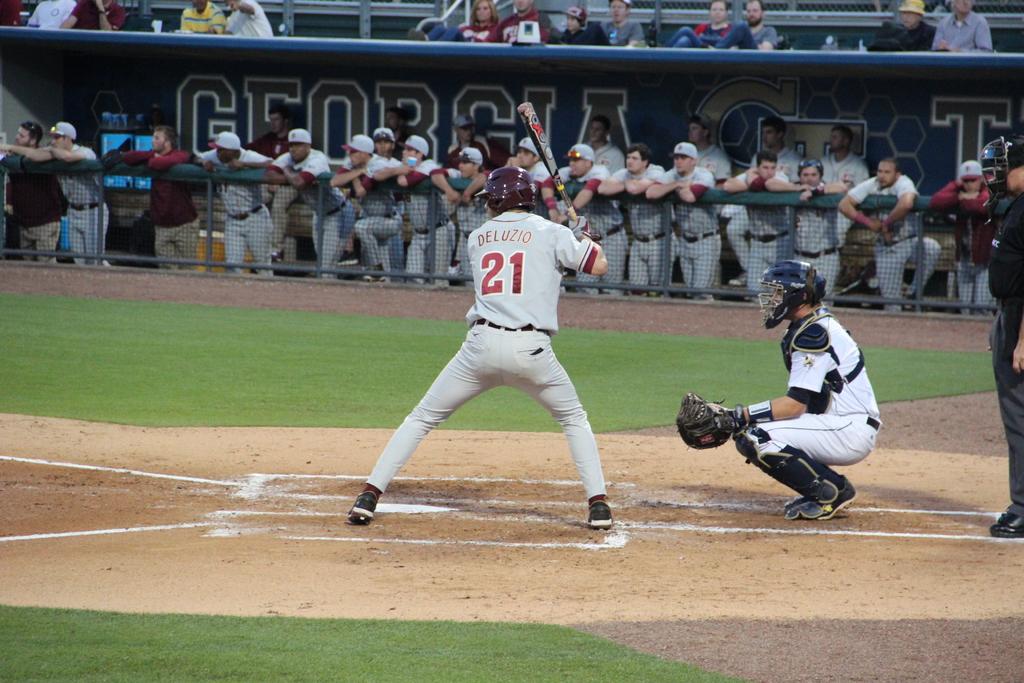What is the name of the batter?
Your answer should be compact. Deluzio. What is the player number?
Ensure brevity in your answer.  21. 